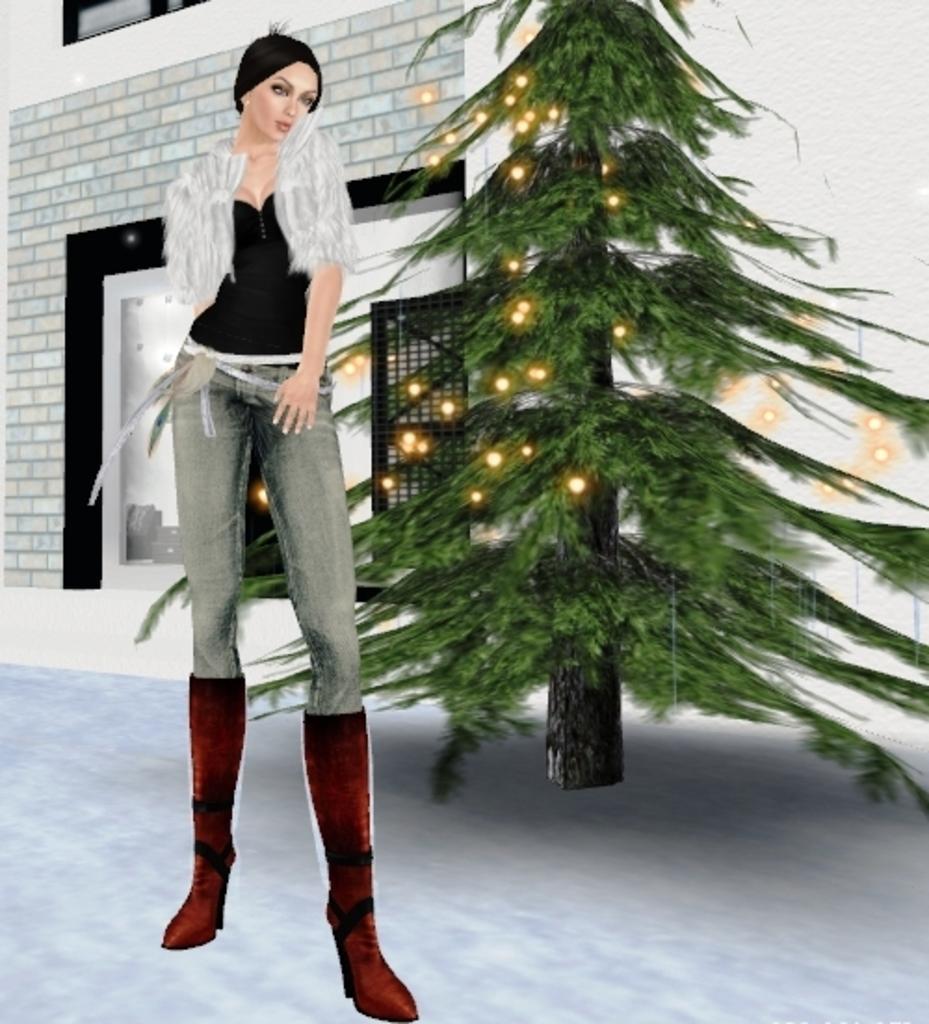Can you describe this image briefly? This picture is an animated image. We can see a lady is standing on the left side of the image. On the right side of the image a christmas tree is there. In the background of the image we can see a wall. At the bottom of the image floor is there. 